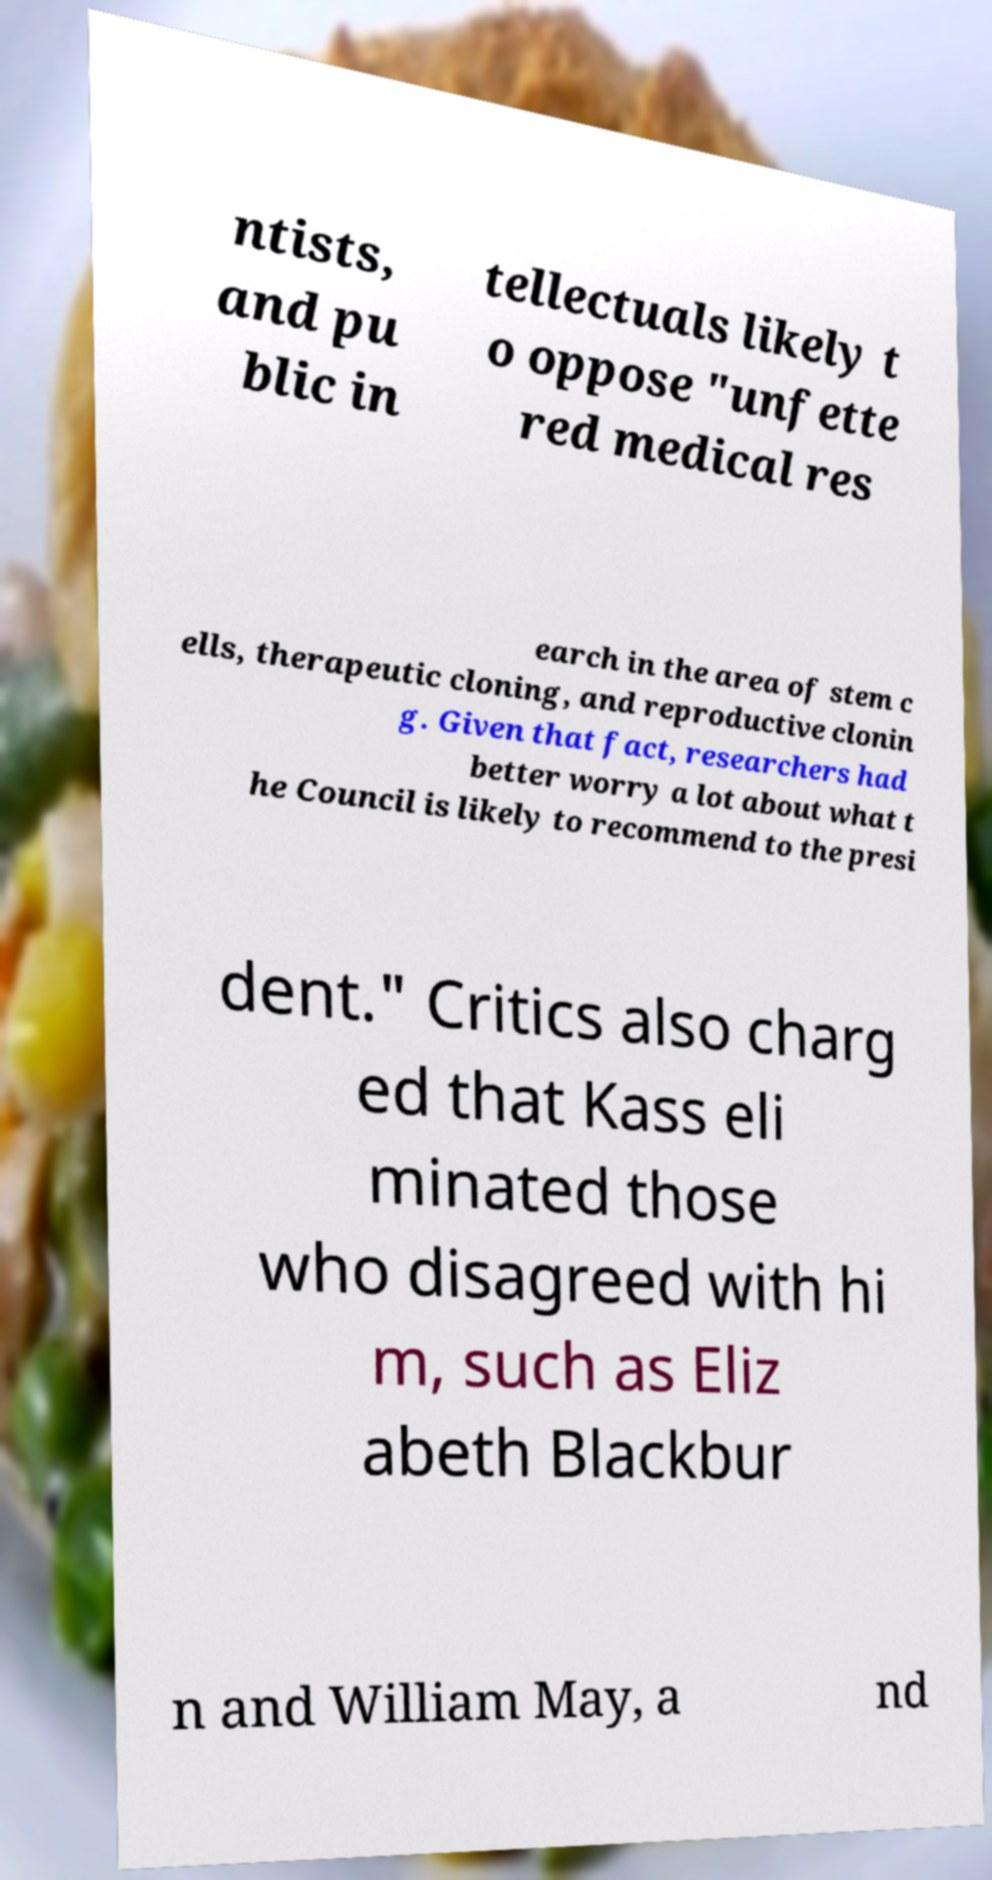For documentation purposes, I need the text within this image transcribed. Could you provide that? ntists, and pu blic in tellectuals likely t o oppose "unfette red medical res earch in the area of stem c ells, therapeutic cloning, and reproductive clonin g. Given that fact, researchers had better worry a lot about what t he Council is likely to recommend to the presi dent." Critics also charg ed that Kass eli minated those who disagreed with hi m, such as Eliz abeth Blackbur n and William May, a nd 